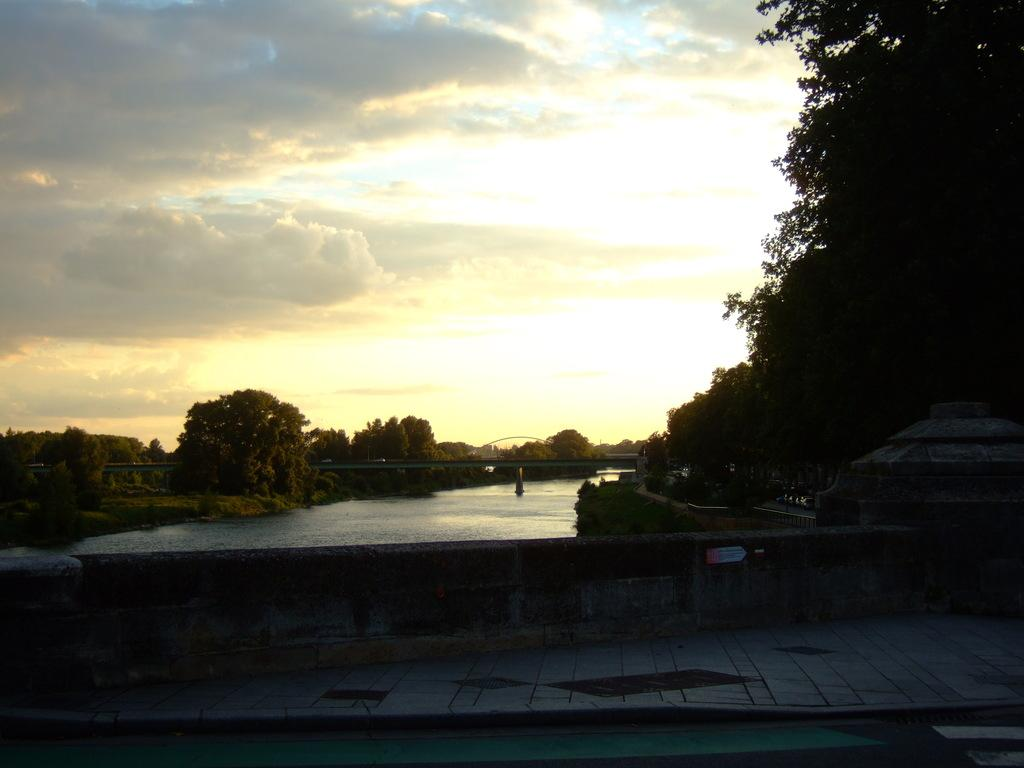What type of natural elements can be seen in the image? There are trees and plants in the image. What man-made structure is present in the image? There is a bridge in the image. What architectural features can be seen in the image? There are pillars and a walkway in the image. What is the condition of the water in the image? Water is visible in the image. What is the weather like in the image? The sky in the background is cloudy. What color crayon is being used to draw the bridge in the image? There is no crayon present in the image, and the bridge is not being drawn. 